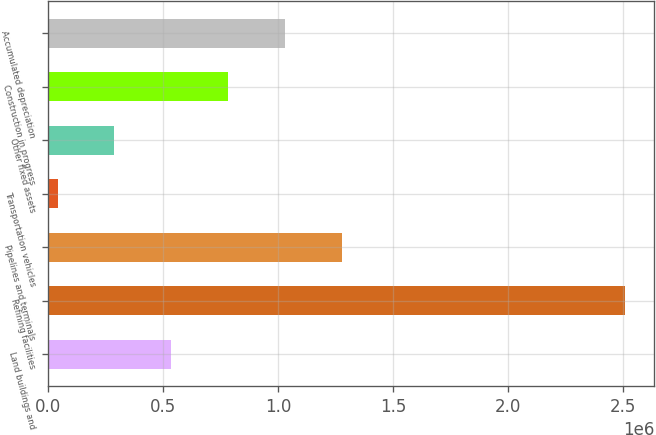Convert chart to OTSL. <chart><loc_0><loc_0><loc_500><loc_500><bar_chart><fcel>Land buildings and<fcel>Refining facilities<fcel>Pipelines and terminals<fcel>Transportation vehicles<fcel>Other fixed assets<fcel>Construction in progress<fcel>Accumulated depreciation<nl><fcel>535003<fcel>2.51075e+06<fcel>1.27591e+06<fcel>41066<fcel>288034<fcel>781971<fcel>1.02894e+06<nl></chart> 